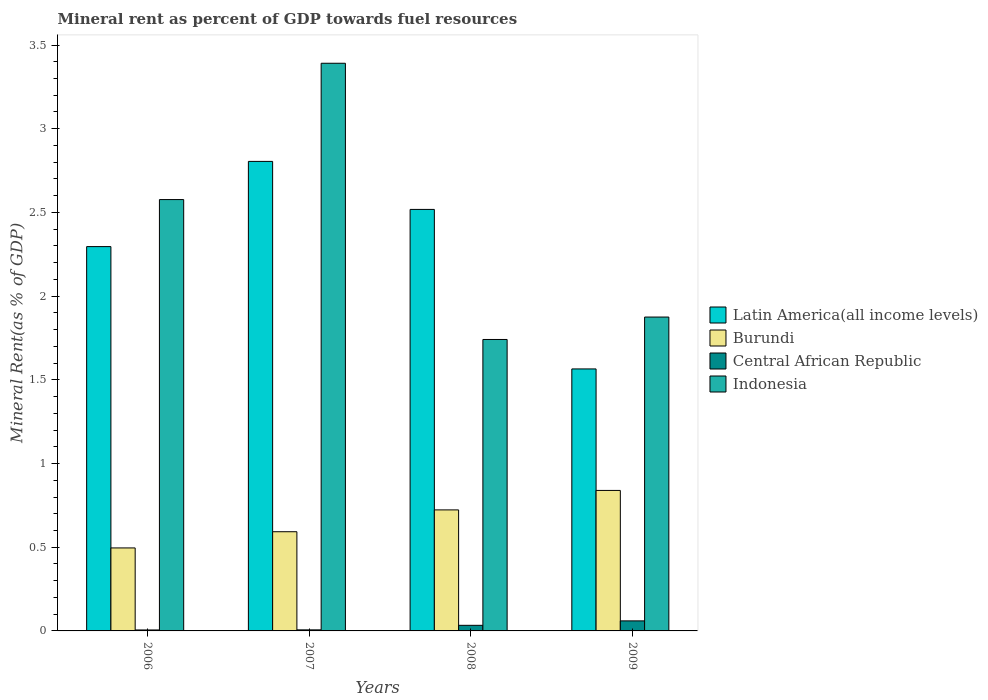How many groups of bars are there?
Your response must be concise. 4. Are the number of bars per tick equal to the number of legend labels?
Make the answer very short. Yes. How many bars are there on the 4th tick from the left?
Give a very brief answer. 4. What is the label of the 2nd group of bars from the left?
Give a very brief answer. 2007. In how many cases, is the number of bars for a given year not equal to the number of legend labels?
Provide a short and direct response. 0. What is the mineral rent in Indonesia in 2008?
Give a very brief answer. 1.74. Across all years, what is the maximum mineral rent in Latin America(all income levels)?
Make the answer very short. 2.8. Across all years, what is the minimum mineral rent in Burundi?
Provide a succinct answer. 0.5. What is the total mineral rent in Central African Republic in the graph?
Your answer should be compact. 0.11. What is the difference between the mineral rent in Indonesia in 2008 and that in 2009?
Your answer should be compact. -0.13. What is the difference between the mineral rent in Burundi in 2008 and the mineral rent in Indonesia in 2006?
Offer a very short reply. -1.85. What is the average mineral rent in Central African Republic per year?
Your answer should be compact. 0.03. In the year 2007, what is the difference between the mineral rent in Indonesia and mineral rent in Burundi?
Make the answer very short. 2.8. What is the ratio of the mineral rent in Burundi in 2006 to that in 2008?
Give a very brief answer. 0.69. Is the mineral rent in Latin America(all income levels) in 2006 less than that in 2008?
Provide a short and direct response. Yes. What is the difference between the highest and the second highest mineral rent in Indonesia?
Provide a short and direct response. 0.81. What is the difference between the highest and the lowest mineral rent in Burundi?
Provide a short and direct response. 0.34. Is the sum of the mineral rent in Latin America(all income levels) in 2006 and 2007 greater than the maximum mineral rent in Indonesia across all years?
Provide a succinct answer. Yes. What does the 2nd bar from the left in 2009 represents?
Offer a terse response. Burundi. What does the 2nd bar from the right in 2007 represents?
Offer a terse response. Central African Republic. Is it the case that in every year, the sum of the mineral rent in Central African Republic and mineral rent in Latin America(all income levels) is greater than the mineral rent in Burundi?
Ensure brevity in your answer.  Yes. Are all the bars in the graph horizontal?
Keep it short and to the point. No. Are the values on the major ticks of Y-axis written in scientific E-notation?
Your response must be concise. No. How are the legend labels stacked?
Ensure brevity in your answer.  Vertical. What is the title of the graph?
Ensure brevity in your answer.  Mineral rent as percent of GDP towards fuel resources. Does "Arab World" appear as one of the legend labels in the graph?
Your answer should be very brief. No. What is the label or title of the Y-axis?
Keep it short and to the point. Mineral Rent(as % of GDP). What is the Mineral Rent(as % of GDP) in Latin America(all income levels) in 2006?
Keep it short and to the point. 2.3. What is the Mineral Rent(as % of GDP) in Burundi in 2006?
Your answer should be compact. 0.5. What is the Mineral Rent(as % of GDP) in Central African Republic in 2006?
Offer a very short reply. 0.01. What is the Mineral Rent(as % of GDP) of Indonesia in 2006?
Provide a short and direct response. 2.58. What is the Mineral Rent(as % of GDP) of Latin America(all income levels) in 2007?
Offer a very short reply. 2.8. What is the Mineral Rent(as % of GDP) in Burundi in 2007?
Ensure brevity in your answer.  0.59. What is the Mineral Rent(as % of GDP) of Central African Republic in 2007?
Keep it short and to the point. 0.01. What is the Mineral Rent(as % of GDP) in Indonesia in 2007?
Keep it short and to the point. 3.39. What is the Mineral Rent(as % of GDP) in Latin America(all income levels) in 2008?
Provide a succinct answer. 2.52. What is the Mineral Rent(as % of GDP) of Burundi in 2008?
Your answer should be very brief. 0.72. What is the Mineral Rent(as % of GDP) of Central African Republic in 2008?
Ensure brevity in your answer.  0.03. What is the Mineral Rent(as % of GDP) in Indonesia in 2008?
Provide a succinct answer. 1.74. What is the Mineral Rent(as % of GDP) in Latin America(all income levels) in 2009?
Give a very brief answer. 1.57. What is the Mineral Rent(as % of GDP) in Burundi in 2009?
Your response must be concise. 0.84. What is the Mineral Rent(as % of GDP) in Central African Republic in 2009?
Keep it short and to the point. 0.06. What is the Mineral Rent(as % of GDP) of Indonesia in 2009?
Keep it short and to the point. 1.87. Across all years, what is the maximum Mineral Rent(as % of GDP) in Latin America(all income levels)?
Make the answer very short. 2.8. Across all years, what is the maximum Mineral Rent(as % of GDP) of Burundi?
Give a very brief answer. 0.84. Across all years, what is the maximum Mineral Rent(as % of GDP) in Central African Republic?
Your answer should be very brief. 0.06. Across all years, what is the maximum Mineral Rent(as % of GDP) in Indonesia?
Offer a terse response. 3.39. Across all years, what is the minimum Mineral Rent(as % of GDP) in Latin America(all income levels)?
Give a very brief answer. 1.57. Across all years, what is the minimum Mineral Rent(as % of GDP) in Burundi?
Keep it short and to the point. 0.5. Across all years, what is the minimum Mineral Rent(as % of GDP) in Central African Republic?
Offer a terse response. 0.01. Across all years, what is the minimum Mineral Rent(as % of GDP) of Indonesia?
Give a very brief answer. 1.74. What is the total Mineral Rent(as % of GDP) in Latin America(all income levels) in the graph?
Keep it short and to the point. 9.18. What is the total Mineral Rent(as % of GDP) in Burundi in the graph?
Your response must be concise. 2.65. What is the total Mineral Rent(as % of GDP) of Central African Republic in the graph?
Your answer should be very brief. 0.11. What is the total Mineral Rent(as % of GDP) in Indonesia in the graph?
Offer a very short reply. 9.58. What is the difference between the Mineral Rent(as % of GDP) of Latin America(all income levels) in 2006 and that in 2007?
Give a very brief answer. -0.51. What is the difference between the Mineral Rent(as % of GDP) of Burundi in 2006 and that in 2007?
Offer a very short reply. -0.1. What is the difference between the Mineral Rent(as % of GDP) of Central African Republic in 2006 and that in 2007?
Keep it short and to the point. -0. What is the difference between the Mineral Rent(as % of GDP) in Indonesia in 2006 and that in 2007?
Provide a succinct answer. -0.81. What is the difference between the Mineral Rent(as % of GDP) in Latin America(all income levels) in 2006 and that in 2008?
Give a very brief answer. -0.22. What is the difference between the Mineral Rent(as % of GDP) in Burundi in 2006 and that in 2008?
Give a very brief answer. -0.23. What is the difference between the Mineral Rent(as % of GDP) in Central African Republic in 2006 and that in 2008?
Offer a terse response. -0.03. What is the difference between the Mineral Rent(as % of GDP) in Indonesia in 2006 and that in 2008?
Your answer should be compact. 0.84. What is the difference between the Mineral Rent(as % of GDP) of Latin America(all income levels) in 2006 and that in 2009?
Offer a terse response. 0.73. What is the difference between the Mineral Rent(as % of GDP) of Burundi in 2006 and that in 2009?
Keep it short and to the point. -0.34. What is the difference between the Mineral Rent(as % of GDP) of Central African Republic in 2006 and that in 2009?
Give a very brief answer. -0.05. What is the difference between the Mineral Rent(as % of GDP) in Indonesia in 2006 and that in 2009?
Provide a short and direct response. 0.7. What is the difference between the Mineral Rent(as % of GDP) of Latin America(all income levels) in 2007 and that in 2008?
Provide a succinct answer. 0.29. What is the difference between the Mineral Rent(as % of GDP) in Burundi in 2007 and that in 2008?
Provide a succinct answer. -0.13. What is the difference between the Mineral Rent(as % of GDP) of Central African Republic in 2007 and that in 2008?
Keep it short and to the point. -0.03. What is the difference between the Mineral Rent(as % of GDP) of Indonesia in 2007 and that in 2008?
Ensure brevity in your answer.  1.65. What is the difference between the Mineral Rent(as % of GDP) in Latin America(all income levels) in 2007 and that in 2009?
Give a very brief answer. 1.24. What is the difference between the Mineral Rent(as % of GDP) of Burundi in 2007 and that in 2009?
Offer a very short reply. -0.25. What is the difference between the Mineral Rent(as % of GDP) in Central African Republic in 2007 and that in 2009?
Make the answer very short. -0.05. What is the difference between the Mineral Rent(as % of GDP) in Indonesia in 2007 and that in 2009?
Make the answer very short. 1.52. What is the difference between the Mineral Rent(as % of GDP) of Latin America(all income levels) in 2008 and that in 2009?
Ensure brevity in your answer.  0.95. What is the difference between the Mineral Rent(as % of GDP) of Burundi in 2008 and that in 2009?
Your answer should be very brief. -0.12. What is the difference between the Mineral Rent(as % of GDP) of Central African Republic in 2008 and that in 2009?
Your answer should be very brief. -0.03. What is the difference between the Mineral Rent(as % of GDP) in Indonesia in 2008 and that in 2009?
Your response must be concise. -0.13. What is the difference between the Mineral Rent(as % of GDP) of Latin America(all income levels) in 2006 and the Mineral Rent(as % of GDP) of Burundi in 2007?
Your answer should be compact. 1.7. What is the difference between the Mineral Rent(as % of GDP) of Latin America(all income levels) in 2006 and the Mineral Rent(as % of GDP) of Central African Republic in 2007?
Offer a very short reply. 2.29. What is the difference between the Mineral Rent(as % of GDP) of Latin America(all income levels) in 2006 and the Mineral Rent(as % of GDP) of Indonesia in 2007?
Give a very brief answer. -1.1. What is the difference between the Mineral Rent(as % of GDP) in Burundi in 2006 and the Mineral Rent(as % of GDP) in Central African Republic in 2007?
Give a very brief answer. 0.49. What is the difference between the Mineral Rent(as % of GDP) of Burundi in 2006 and the Mineral Rent(as % of GDP) of Indonesia in 2007?
Give a very brief answer. -2.9. What is the difference between the Mineral Rent(as % of GDP) in Central African Republic in 2006 and the Mineral Rent(as % of GDP) in Indonesia in 2007?
Provide a succinct answer. -3.39. What is the difference between the Mineral Rent(as % of GDP) of Latin America(all income levels) in 2006 and the Mineral Rent(as % of GDP) of Burundi in 2008?
Provide a short and direct response. 1.57. What is the difference between the Mineral Rent(as % of GDP) in Latin America(all income levels) in 2006 and the Mineral Rent(as % of GDP) in Central African Republic in 2008?
Offer a terse response. 2.26. What is the difference between the Mineral Rent(as % of GDP) of Latin America(all income levels) in 2006 and the Mineral Rent(as % of GDP) of Indonesia in 2008?
Your answer should be compact. 0.55. What is the difference between the Mineral Rent(as % of GDP) in Burundi in 2006 and the Mineral Rent(as % of GDP) in Central African Republic in 2008?
Ensure brevity in your answer.  0.46. What is the difference between the Mineral Rent(as % of GDP) of Burundi in 2006 and the Mineral Rent(as % of GDP) of Indonesia in 2008?
Offer a very short reply. -1.25. What is the difference between the Mineral Rent(as % of GDP) in Central African Republic in 2006 and the Mineral Rent(as % of GDP) in Indonesia in 2008?
Give a very brief answer. -1.74. What is the difference between the Mineral Rent(as % of GDP) in Latin America(all income levels) in 2006 and the Mineral Rent(as % of GDP) in Burundi in 2009?
Keep it short and to the point. 1.46. What is the difference between the Mineral Rent(as % of GDP) in Latin America(all income levels) in 2006 and the Mineral Rent(as % of GDP) in Central African Republic in 2009?
Make the answer very short. 2.24. What is the difference between the Mineral Rent(as % of GDP) of Latin America(all income levels) in 2006 and the Mineral Rent(as % of GDP) of Indonesia in 2009?
Give a very brief answer. 0.42. What is the difference between the Mineral Rent(as % of GDP) of Burundi in 2006 and the Mineral Rent(as % of GDP) of Central African Republic in 2009?
Provide a short and direct response. 0.44. What is the difference between the Mineral Rent(as % of GDP) of Burundi in 2006 and the Mineral Rent(as % of GDP) of Indonesia in 2009?
Ensure brevity in your answer.  -1.38. What is the difference between the Mineral Rent(as % of GDP) in Central African Republic in 2006 and the Mineral Rent(as % of GDP) in Indonesia in 2009?
Provide a short and direct response. -1.87. What is the difference between the Mineral Rent(as % of GDP) of Latin America(all income levels) in 2007 and the Mineral Rent(as % of GDP) of Burundi in 2008?
Provide a short and direct response. 2.08. What is the difference between the Mineral Rent(as % of GDP) in Latin America(all income levels) in 2007 and the Mineral Rent(as % of GDP) in Central African Republic in 2008?
Your answer should be very brief. 2.77. What is the difference between the Mineral Rent(as % of GDP) of Latin America(all income levels) in 2007 and the Mineral Rent(as % of GDP) of Indonesia in 2008?
Keep it short and to the point. 1.06. What is the difference between the Mineral Rent(as % of GDP) in Burundi in 2007 and the Mineral Rent(as % of GDP) in Central African Republic in 2008?
Your answer should be very brief. 0.56. What is the difference between the Mineral Rent(as % of GDP) of Burundi in 2007 and the Mineral Rent(as % of GDP) of Indonesia in 2008?
Your response must be concise. -1.15. What is the difference between the Mineral Rent(as % of GDP) of Central African Republic in 2007 and the Mineral Rent(as % of GDP) of Indonesia in 2008?
Provide a succinct answer. -1.73. What is the difference between the Mineral Rent(as % of GDP) of Latin America(all income levels) in 2007 and the Mineral Rent(as % of GDP) of Burundi in 2009?
Offer a very short reply. 1.97. What is the difference between the Mineral Rent(as % of GDP) of Latin America(all income levels) in 2007 and the Mineral Rent(as % of GDP) of Central African Republic in 2009?
Your answer should be compact. 2.74. What is the difference between the Mineral Rent(as % of GDP) in Latin America(all income levels) in 2007 and the Mineral Rent(as % of GDP) in Indonesia in 2009?
Keep it short and to the point. 0.93. What is the difference between the Mineral Rent(as % of GDP) of Burundi in 2007 and the Mineral Rent(as % of GDP) of Central African Republic in 2009?
Offer a very short reply. 0.53. What is the difference between the Mineral Rent(as % of GDP) in Burundi in 2007 and the Mineral Rent(as % of GDP) in Indonesia in 2009?
Keep it short and to the point. -1.28. What is the difference between the Mineral Rent(as % of GDP) in Central African Republic in 2007 and the Mineral Rent(as % of GDP) in Indonesia in 2009?
Your response must be concise. -1.87. What is the difference between the Mineral Rent(as % of GDP) in Latin America(all income levels) in 2008 and the Mineral Rent(as % of GDP) in Burundi in 2009?
Provide a succinct answer. 1.68. What is the difference between the Mineral Rent(as % of GDP) in Latin America(all income levels) in 2008 and the Mineral Rent(as % of GDP) in Central African Republic in 2009?
Provide a succinct answer. 2.46. What is the difference between the Mineral Rent(as % of GDP) in Latin America(all income levels) in 2008 and the Mineral Rent(as % of GDP) in Indonesia in 2009?
Your answer should be compact. 0.64. What is the difference between the Mineral Rent(as % of GDP) of Burundi in 2008 and the Mineral Rent(as % of GDP) of Central African Republic in 2009?
Keep it short and to the point. 0.66. What is the difference between the Mineral Rent(as % of GDP) of Burundi in 2008 and the Mineral Rent(as % of GDP) of Indonesia in 2009?
Offer a very short reply. -1.15. What is the difference between the Mineral Rent(as % of GDP) of Central African Republic in 2008 and the Mineral Rent(as % of GDP) of Indonesia in 2009?
Make the answer very short. -1.84. What is the average Mineral Rent(as % of GDP) of Latin America(all income levels) per year?
Keep it short and to the point. 2.3. What is the average Mineral Rent(as % of GDP) of Burundi per year?
Ensure brevity in your answer.  0.66. What is the average Mineral Rent(as % of GDP) in Central African Republic per year?
Keep it short and to the point. 0.03. What is the average Mineral Rent(as % of GDP) in Indonesia per year?
Give a very brief answer. 2.4. In the year 2006, what is the difference between the Mineral Rent(as % of GDP) of Latin America(all income levels) and Mineral Rent(as % of GDP) of Central African Republic?
Your answer should be very brief. 2.29. In the year 2006, what is the difference between the Mineral Rent(as % of GDP) in Latin America(all income levels) and Mineral Rent(as % of GDP) in Indonesia?
Offer a terse response. -0.28. In the year 2006, what is the difference between the Mineral Rent(as % of GDP) in Burundi and Mineral Rent(as % of GDP) in Central African Republic?
Keep it short and to the point. 0.49. In the year 2006, what is the difference between the Mineral Rent(as % of GDP) in Burundi and Mineral Rent(as % of GDP) in Indonesia?
Offer a terse response. -2.08. In the year 2006, what is the difference between the Mineral Rent(as % of GDP) of Central African Republic and Mineral Rent(as % of GDP) of Indonesia?
Offer a terse response. -2.57. In the year 2007, what is the difference between the Mineral Rent(as % of GDP) in Latin America(all income levels) and Mineral Rent(as % of GDP) in Burundi?
Give a very brief answer. 2.21. In the year 2007, what is the difference between the Mineral Rent(as % of GDP) in Latin America(all income levels) and Mineral Rent(as % of GDP) in Central African Republic?
Make the answer very short. 2.8. In the year 2007, what is the difference between the Mineral Rent(as % of GDP) of Latin America(all income levels) and Mineral Rent(as % of GDP) of Indonesia?
Provide a succinct answer. -0.59. In the year 2007, what is the difference between the Mineral Rent(as % of GDP) of Burundi and Mineral Rent(as % of GDP) of Central African Republic?
Your answer should be very brief. 0.59. In the year 2007, what is the difference between the Mineral Rent(as % of GDP) of Burundi and Mineral Rent(as % of GDP) of Indonesia?
Offer a very short reply. -2.8. In the year 2007, what is the difference between the Mineral Rent(as % of GDP) of Central African Republic and Mineral Rent(as % of GDP) of Indonesia?
Offer a terse response. -3.38. In the year 2008, what is the difference between the Mineral Rent(as % of GDP) in Latin America(all income levels) and Mineral Rent(as % of GDP) in Burundi?
Provide a short and direct response. 1.79. In the year 2008, what is the difference between the Mineral Rent(as % of GDP) in Latin America(all income levels) and Mineral Rent(as % of GDP) in Central African Republic?
Offer a terse response. 2.48. In the year 2008, what is the difference between the Mineral Rent(as % of GDP) of Latin America(all income levels) and Mineral Rent(as % of GDP) of Indonesia?
Your answer should be compact. 0.78. In the year 2008, what is the difference between the Mineral Rent(as % of GDP) of Burundi and Mineral Rent(as % of GDP) of Central African Republic?
Provide a short and direct response. 0.69. In the year 2008, what is the difference between the Mineral Rent(as % of GDP) in Burundi and Mineral Rent(as % of GDP) in Indonesia?
Keep it short and to the point. -1.02. In the year 2008, what is the difference between the Mineral Rent(as % of GDP) of Central African Republic and Mineral Rent(as % of GDP) of Indonesia?
Offer a very short reply. -1.71. In the year 2009, what is the difference between the Mineral Rent(as % of GDP) in Latin America(all income levels) and Mineral Rent(as % of GDP) in Burundi?
Keep it short and to the point. 0.73. In the year 2009, what is the difference between the Mineral Rent(as % of GDP) in Latin America(all income levels) and Mineral Rent(as % of GDP) in Central African Republic?
Offer a very short reply. 1.51. In the year 2009, what is the difference between the Mineral Rent(as % of GDP) in Latin America(all income levels) and Mineral Rent(as % of GDP) in Indonesia?
Offer a very short reply. -0.31. In the year 2009, what is the difference between the Mineral Rent(as % of GDP) of Burundi and Mineral Rent(as % of GDP) of Central African Republic?
Your answer should be very brief. 0.78. In the year 2009, what is the difference between the Mineral Rent(as % of GDP) in Burundi and Mineral Rent(as % of GDP) in Indonesia?
Keep it short and to the point. -1.04. In the year 2009, what is the difference between the Mineral Rent(as % of GDP) in Central African Republic and Mineral Rent(as % of GDP) in Indonesia?
Your response must be concise. -1.81. What is the ratio of the Mineral Rent(as % of GDP) of Latin America(all income levels) in 2006 to that in 2007?
Offer a very short reply. 0.82. What is the ratio of the Mineral Rent(as % of GDP) of Burundi in 2006 to that in 2007?
Provide a short and direct response. 0.84. What is the ratio of the Mineral Rent(as % of GDP) of Central African Republic in 2006 to that in 2007?
Keep it short and to the point. 0.91. What is the ratio of the Mineral Rent(as % of GDP) in Indonesia in 2006 to that in 2007?
Make the answer very short. 0.76. What is the ratio of the Mineral Rent(as % of GDP) in Latin America(all income levels) in 2006 to that in 2008?
Offer a very short reply. 0.91. What is the ratio of the Mineral Rent(as % of GDP) of Burundi in 2006 to that in 2008?
Provide a short and direct response. 0.69. What is the ratio of the Mineral Rent(as % of GDP) in Central African Republic in 2006 to that in 2008?
Give a very brief answer. 0.17. What is the ratio of the Mineral Rent(as % of GDP) of Indonesia in 2006 to that in 2008?
Make the answer very short. 1.48. What is the ratio of the Mineral Rent(as % of GDP) in Latin America(all income levels) in 2006 to that in 2009?
Provide a succinct answer. 1.47. What is the ratio of the Mineral Rent(as % of GDP) in Burundi in 2006 to that in 2009?
Provide a succinct answer. 0.59. What is the ratio of the Mineral Rent(as % of GDP) in Central African Republic in 2006 to that in 2009?
Make the answer very short. 0.1. What is the ratio of the Mineral Rent(as % of GDP) in Indonesia in 2006 to that in 2009?
Provide a succinct answer. 1.37. What is the ratio of the Mineral Rent(as % of GDP) in Latin America(all income levels) in 2007 to that in 2008?
Your answer should be compact. 1.11. What is the ratio of the Mineral Rent(as % of GDP) of Burundi in 2007 to that in 2008?
Provide a short and direct response. 0.82. What is the ratio of the Mineral Rent(as % of GDP) in Central African Republic in 2007 to that in 2008?
Your response must be concise. 0.19. What is the ratio of the Mineral Rent(as % of GDP) of Indonesia in 2007 to that in 2008?
Provide a succinct answer. 1.95. What is the ratio of the Mineral Rent(as % of GDP) of Latin America(all income levels) in 2007 to that in 2009?
Provide a short and direct response. 1.79. What is the ratio of the Mineral Rent(as % of GDP) in Burundi in 2007 to that in 2009?
Make the answer very short. 0.71. What is the ratio of the Mineral Rent(as % of GDP) in Central African Republic in 2007 to that in 2009?
Provide a succinct answer. 0.11. What is the ratio of the Mineral Rent(as % of GDP) of Indonesia in 2007 to that in 2009?
Ensure brevity in your answer.  1.81. What is the ratio of the Mineral Rent(as % of GDP) in Latin America(all income levels) in 2008 to that in 2009?
Your response must be concise. 1.61. What is the ratio of the Mineral Rent(as % of GDP) of Burundi in 2008 to that in 2009?
Your response must be concise. 0.86. What is the ratio of the Mineral Rent(as % of GDP) of Central African Republic in 2008 to that in 2009?
Offer a terse response. 0.56. What is the ratio of the Mineral Rent(as % of GDP) in Indonesia in 2008 to that in 2009?
Provide a short and direct response. 0.93. What is the difference between the highest and the second highest Mineral Rent(as % of GDP) of Latin America(all income levels)?
Your response must be concise. 0.29. What is the difference between the highest and the second highest Mineral Rent(as % of GDP) in Burundi?
Offer a very short reply. 0.12. What is the difference between the highest and the second highest Mineral Rent(as % of GDP) of Central African Republic?
Provide a short and direct response. 0.03. What is the difference between the highest and the second highest Mineral Rent(as % of GDP) of Indonesia?
Give a very brief answer. 0.81. What is the difference between the highest and the lowest Mineral Rent(as % of GDP) of Latin America(all income levels)?
Your answer should be very brief. 1.24. What is the difference between the highest and the lowest Mineral Rent(as % of GDP) in Burundi?
Your answer should be compact. 0.34. What is the difference between the highest and the lowest Mineral Rent(as % of GDP) of Central African Republic?
Your response must be concise. 0.05. What is the difference between the highest and the lowest Mineral Rent(as % of GDP) in Indonesia?
Provide a short and direct response. 1.65. 